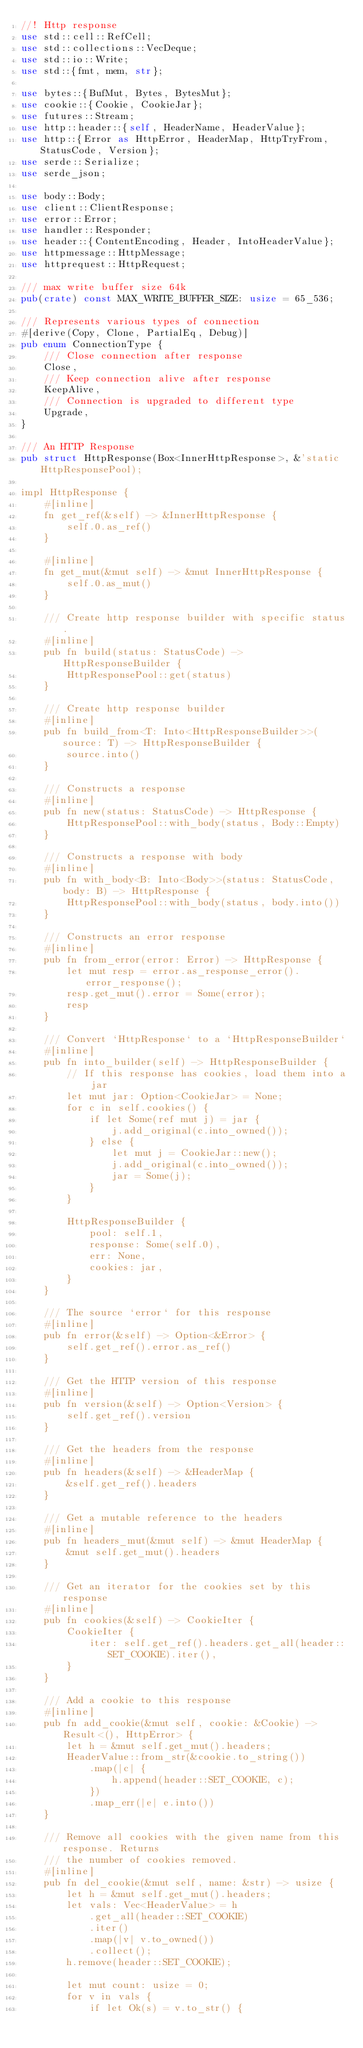Convert code to text. <code><loc_0><loc_0><loc_500><loc_500><_Rust_>//! Http response
use std::cell::RefCell;
use std::collections::VecDeque;
use std::io::Write;
use std::{fmt, mem, str};

use bytes::{BufMut, Bytes, BytesMut};
use cookie::{Cookie, CookieJar};
use futures::Stream;
use http::header::{self, HeaderName, HeaderValue};
use http::{Error as HttpError, HeaderMap, HttpTryFrom, StatusCode, Version};
use serde::Serialize;
use serde_json;

use body::Body;
use client::ClientResponse;
use error::Error;
use handler::Responder;
use header::{ContentEncoding, Header, IntoHeaderValue};
use httpmessage::HttpMessage;
use httprequest::HttpRequest;

/// max write buffer size 64k
pub(crate) const MAX_WRITE_BUFFER_SIZE: usize = 65_536;

/// Represents various types of connection
#[derive(Copy, Clone, PartialEq, Debug)]
pub enum ConnectionType {
    /// Close connection after response
    Close,
    /// Keep connection alive after response
    KeepAlive,
    /// Connection is upgraded to different type
    Upgrade,
}

/// An HTTP Response
pub struct HttpResponse(Box<InnerHttpResponse>, &'static HttpResponsePool);

impl HttpResponse {
    #[inline]
    fn get_ref(&self) -> &InnerHttpResponse {
        self.0.as_ref()
    }

    #[inline]
    fn get_mut(&mut self) -> &mut InnerHttpResponse {
        self.0.as_mut()
    }

    /// Create http response builder with specific status.
    #[inline]
    pub fn build(status: StatusCode) -> HttpResponseBuilder {
        HttpResponsePool::get(status)
    }

    /// Create http response builder
    #[inline]
    pub fn build_from<T: Into<HttpResponseBuilder>>(source: T) -> HttpResponseBuilder {
        source.into()
    }

    /// Constructs a response
    #[inline]
    pub fn new(status: StatusCode) -> HttpResponse {
        HttpResponsePool::with_body(status, Body::Empty)
    }

    /// Constructs a response with body
    #[inline]
    pub fn with_body<B: Into<Body>>(status: StatusCode, body: B) -> HttpResponse {
        HttpResponsePool::with_body(status, body.into())
    }

    /// Constructs an error response
    #[inline]
    pub fn from_error(error: Error) -> HttpResponse {
        let mut resp = error.as_response_error().error_response();
        resp.get_mut().error = Some(error);
        resp
    }

    /// Convert `HttpResponse` to a `HttpResponseBuilder`
    #[inline]
    pub fn into_builder(self) -> HttpResponseBuilder {
        // If this response has cookies, load them into a jar
        let mut jar: Option<CookieJar> = None;
        for c in self.cookies() {
            if let Some(ref mut j) = jar {
                j.add_original(c.into_owned());
            } else {
                let mut j = CookieJar::new();
                j.add_original(c.into_owned());
                jar = Some(j);
            }
        }

        HttpResponseBuilder {
            pool: self.1,
            response: Some(self.0),
            err: None,
            cookies: jar,
        }
    }

    /// The source `error` for this response
    #[inline]
    pub fn error(&self) -> Option<&Error> {
        self.get_ref().error.as_ref()
    }

    /// Get the HTTP version of this response
    #[inline]
    pub fn version(&self) -> Option<Version> {
        self.get_ref().version
    }

    /// Get the headers from the response
    #[inline]
    pub fn headers(&self) -> &HeaderMap {
        &self.get_ref().headers
    }

    /// Get a mutable reference to the headers
    #[inline]
    pub fn headers_mut(&mut self) -> &mut HeaderMap {
        &mut self.get_mut().headers
    }

    /// Get an iterator for the cookies set by this response
    #[inline]
    pub fn cookies(&self) -> CookieIter {
        CookieIter {
            iter: self.get_ref().headers.get_all(header::SET_COOKIE).iter(),
        }
    }

    /// Add a cookie to this response
    #[inline]
    pub fn add_cookie(&mut self, cookie: &Cookie) -> Result<(), HttpError> {
        let h = &mut self.get_mut().headers;
        HeaderValue::from_str(&cookie.to_string())
            .map(|c| {
                h.append(header::SET_COOKIE, c);
            })
            .map_err(|e| e.into())
    }

    /// Remove all cookies with the given name from this response. Returns
    /// the number of cookies removed.
    #[inline]
    pub fn del_cookie(&mut self, name: &str) -> usize {
        let h = &mut self.get_mut().headers;
        let vals: Vec<HeaderValue> = h
            .get_all(header::SET_COOKIE)
            .iter()
            .map(|v| v.to_owned())
            .collect();
        h.remove(header::SET_COOKIE);

        let mut count: usize = 0;
        for v in vals {
            if let Ok(s) = v.to_str() {</code> 